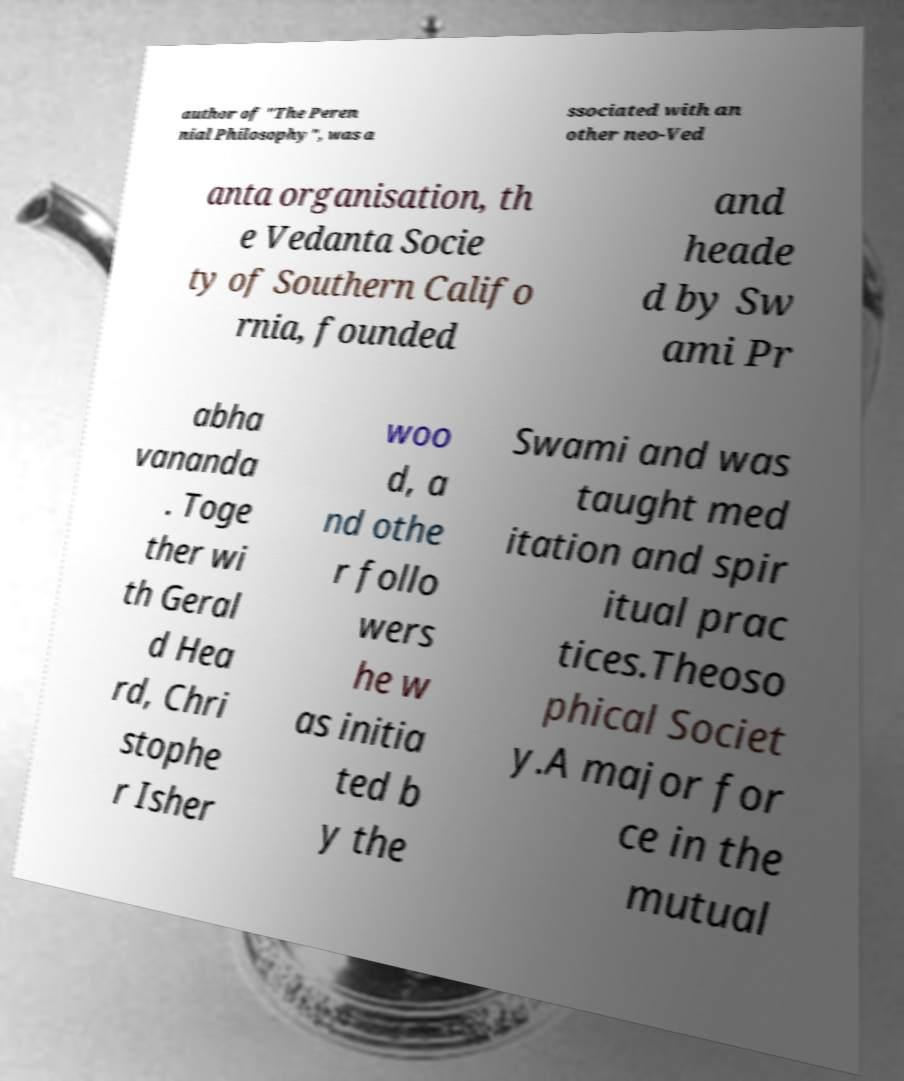Could you extract and type out the text from this image? author of "The Peren nial Philosophy", was a ssociated with an other neo-Ved anta organisation, th e Vedanta Socie ty of Southern Califo rnia, founded and heade d by Sw ami Pr abha vananda . Toge ther wi th Geral d Hea rd, Chri stophe r Isher woo d, a nd othe r follo wers he w as initia ted b y the Swami and was taught med itation and spir itual prac tices.Theoso phical Societ y.A major for ce in the mutual 